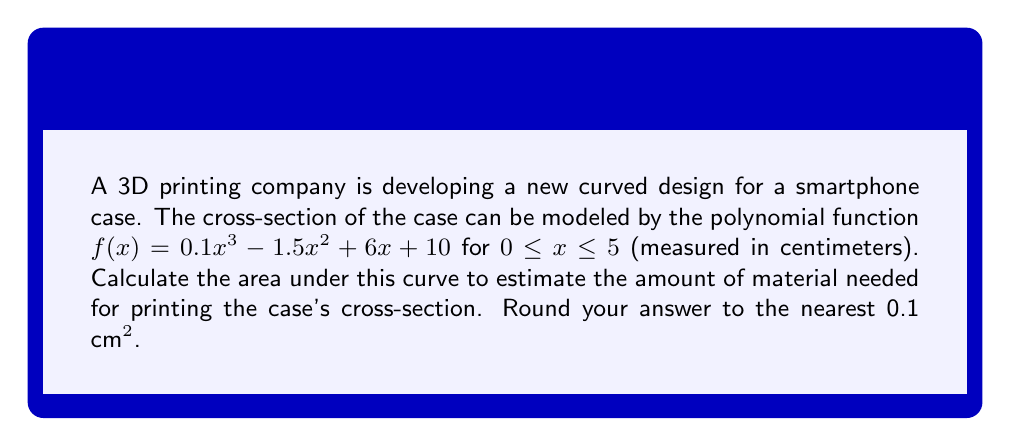Help me with this question. To calculate the area under the polynomial curve, we need to integrate the function $f(x)$ over the given interval $[0, 5]$. Here's the step-by-step process:

1) The area is given by the definite integral:
   $$A = \int_0^5 (0.1x^3 - 1.5x^2 + 6x + 10) dx$$

2) Integrate each term:
   $$A = \left[\frac{0.1x^4}{4} - \frac{1.5x^3}{3} + 3x^2 + 10x\right]_0^5$$

3) Evaluate the integral at the upper and lower bounds:
   $$A = \left(\frac{0.1(5^4)}{4} - \frac{1.5(5^3)}{3} + 3(5^2) + 10(5)\right) - \left(\frac{0.1(0^4)}{4} - \frac{1.5(0^3)}{3} + 3(0^2) + 10(0)\right)$$

4) Simplify:
   $$A = (31.25 - 62.5 + 75 + 50) - (0 - 0 + 0 + 0)$$
   $$A = 93.75 - 0 = 93.75$$

5) Round to the nearest 0.1:
   $$A \approx 93.8 \text{ cm}^2$$

Therefore, the estimated amount of material needed for printing the case's cross-section is approximately 93.8 cm².
Answer: 93.8 cm² 